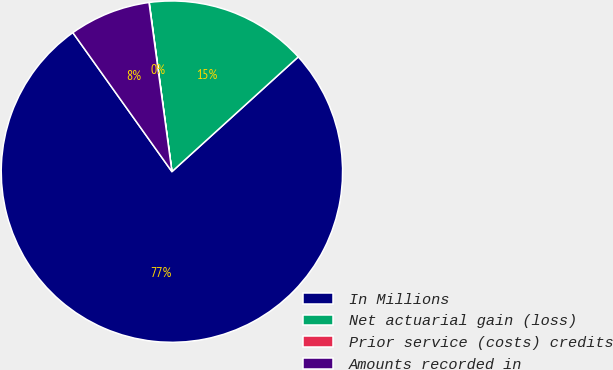Convert chart. <chart><loc_0><loc_0><loc_500><loc_500><pie_chart><fcel>In Millions<fcel>Net actuarial gain (loss)<fcel>Prior service (costs) credits<fcel>Amounts recorded in<nl><fcel>76.88%<fcel>15.39%<fcel>0.02%<fcel>7.71%<nl></chart> 